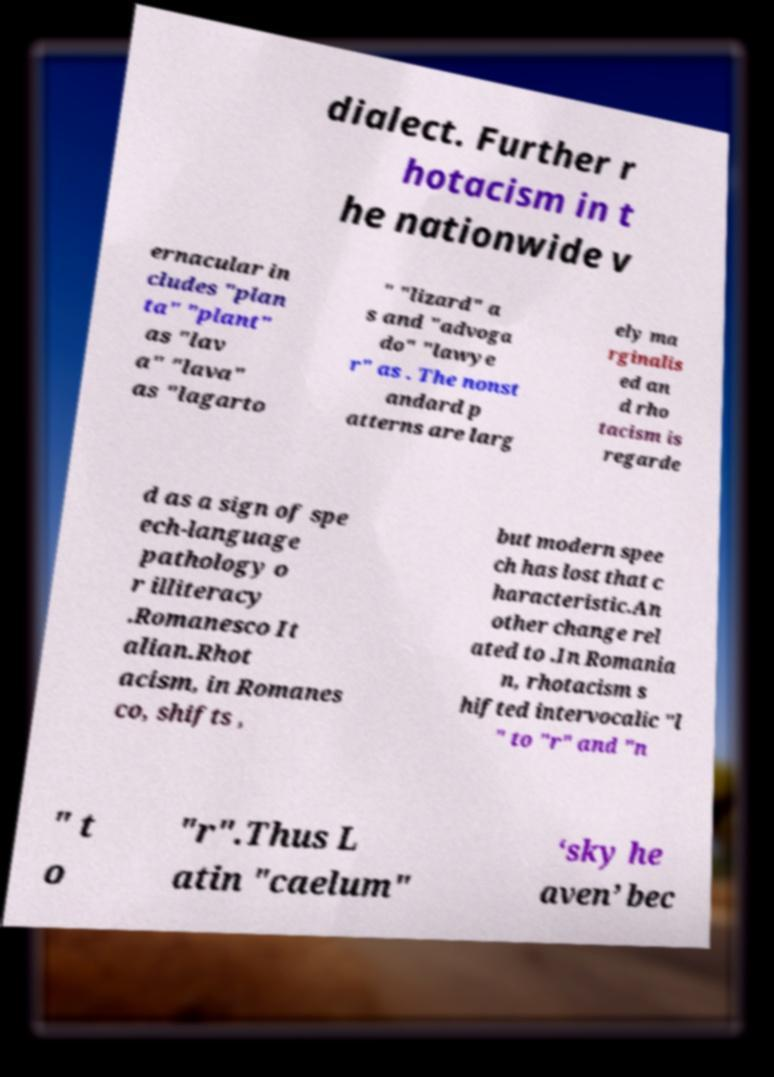Can you accurately transcribe the text from the provided image for me? dialect. Further r hotacism in t he nationwide v ernacular in cludes "plan ta" "plant" as "lav a" "lava" as "lagarto " "lizard" a s and "advoga do" "lawye r" as . The nonst andard p atterns are larg ely ma rginalis ed an d rho tacism is regarde d as a sign of spe ech-language pathology o r illiteracy .Romanesco It alian.Rhot acism, in Romanes co, shifts , but modern spee ch has lost that c haracteristic.An other change rel ated to .In Romania n, rhotacism s hifted intervocalic "l " to "r" and "n " t o "r".Thus L atin "caelum" ‘sky he aven’ bec 